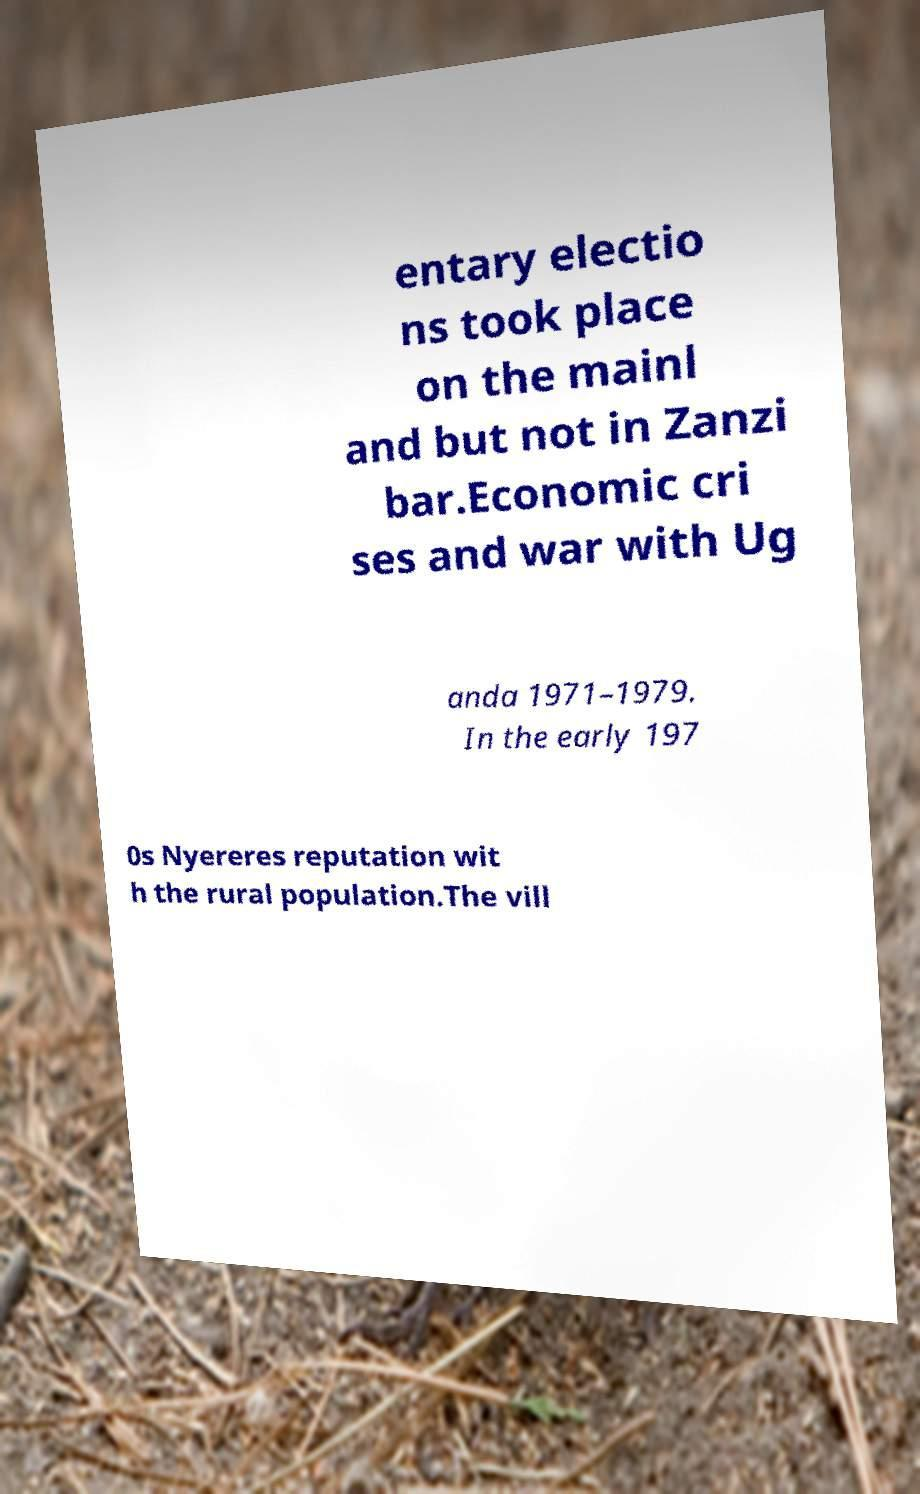What messages or text are displayed in this image? I need them in a readable, typed format. entary electio ns took place on the mainl and but not in Zanzi bar.Economic cri ses and war with Ug anda 1971–1979. In the early 197 0s Nyereres reputation wit h the rural population.The vill 